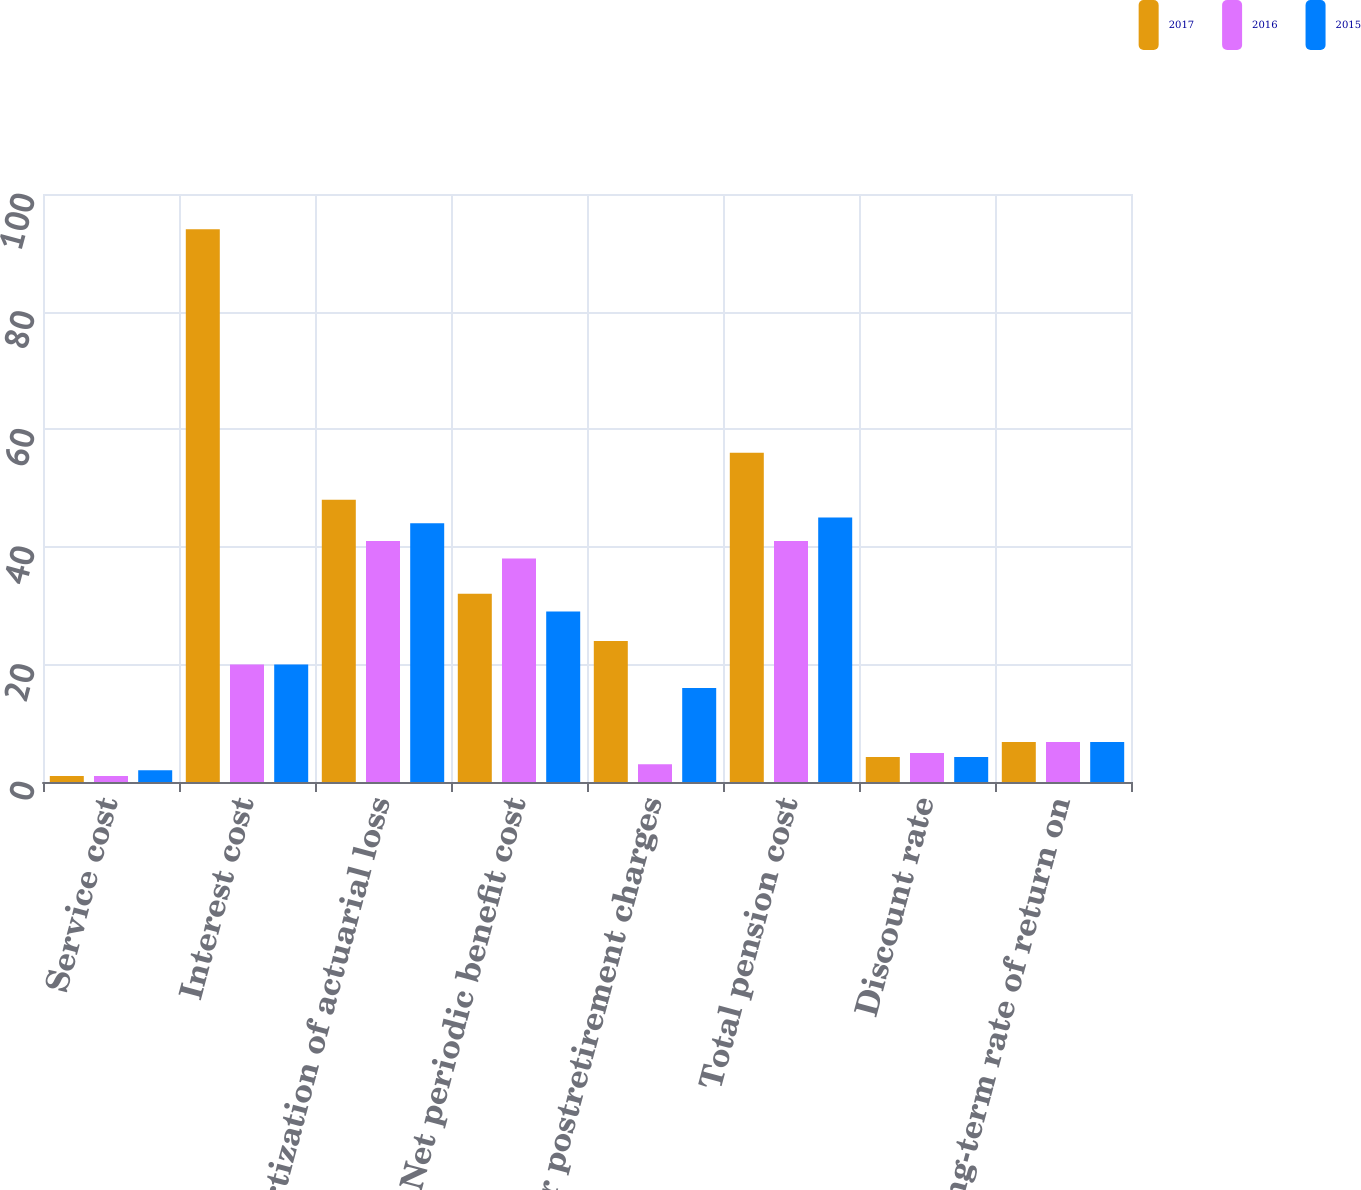<chart> <loc_0><loc_0><loc_500><loc_500><stacked_bar_chart><ecel><fcel>Service cost<fcel>Interest cost<fcel>Amortization of actuarial loss<fcel>Net periodic benefit cost<fcel>Other postretirement charges<fcel>Total pension cost<fcel>Discount rate<fcel>Long-term rate of return on<nl><fcel>2017<fcel>1<fcel>94<fcel>48<fcel>32<fcel>24<fcel>56<fcel>4.27<fcel>6.8<nl><fcel>2016<fcel>1<fcel>20<fcel>41<fcel>38<fcel>3<fcel>41<fcel>4.93<fcel>6.8<nl><fcel>2015<fcel>2<fcel>20<fcel>44<fcel>29<fcel>16<fcel>45<fcel>4.24<fcel>6.8<nl></chart> 